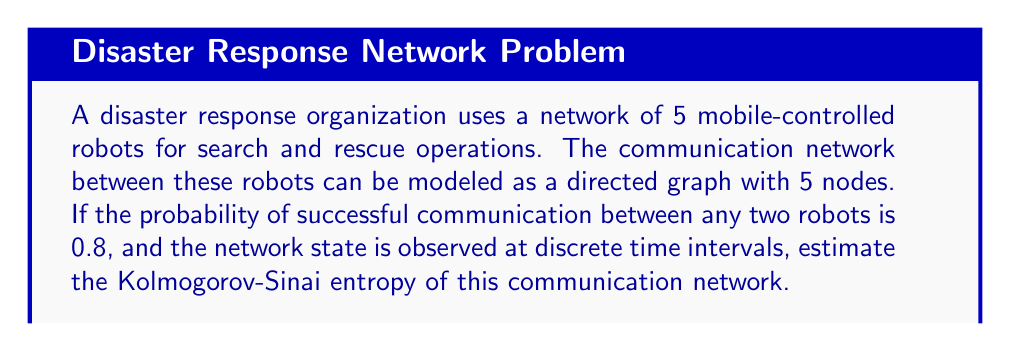Solve this math problem. To estimate the Kolmogorov-Sinai entropy of the communication network, we'll follow these steps:

1) First, we need to determine the number of possible states for each link in the network. Since the communication is either successful (1) or unsuccessful (0), there are 2 possible states for each link.

2) In a directed graph with 5 nodes, there are $5 * 4 = 20$ possible links (excluding self-loops).

3) The total number of possible network states is thus $2^{20}$.

4) The probability of each state can be calculated. For a given state with $k$ successful links:

   $P(\text{state}) = 0.8^k * 0.2^{(20-k)}$

5) The Kolmogorov-Sinai entropy is the sum of the product of each state's probability and its natural logarithm:

   $H = -\sum_{i=1}^{2^{20}} P_i \ln(P_i)$

6) However, calculating this exactly would be computationally intensive. We can estimate it using the average case:

   On average, 16 out of 20 links will be successful (0.8 * 20 = 16).

7) The probability of this average state is:

   $P(\text{avg state}) = 0.8^{16} * 0.2^4 \approx 0.0106$

8) Estimating the entropy using this average state:

   $H \approx -2^{20} * 0.0106 * \ln(0.0106)$

9) Calculating:

   $H \approx 1,048,576 * 0.0106 * 4.5469 \approx 50,803$ bits

This is an estimate of the Kolmogorov-Sinai entropy per time step of observation.
Answer: $\approx 50,803$ bits 